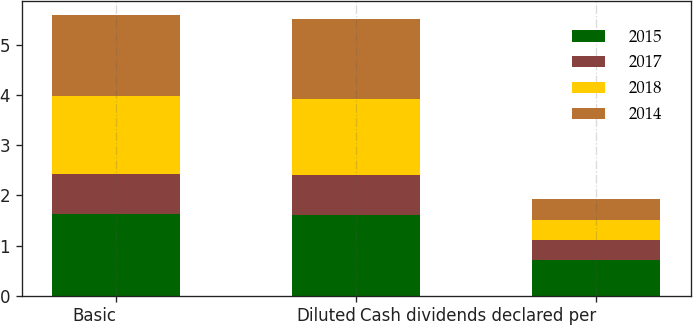<chart> <loc_0><loc_0><loc_500><loc_500><stacked_bar_chart><ecel><fcel>Basic<fcel>Diluted<fcel>Cash dividends declared per<nl><fcel>2015<fcel>1.62<fcel>1.6<fcel>0.72<nl><fcel>2017<fcel>0.81<fcel>0.8<fcel>0.4<nl><fcel>2018<fcel>1.55<fcel>1.53<fcel>0.4<nl><fcel>2014<fcel>1.62<fcel>1.59<fcel>0.4<nl></chart> 